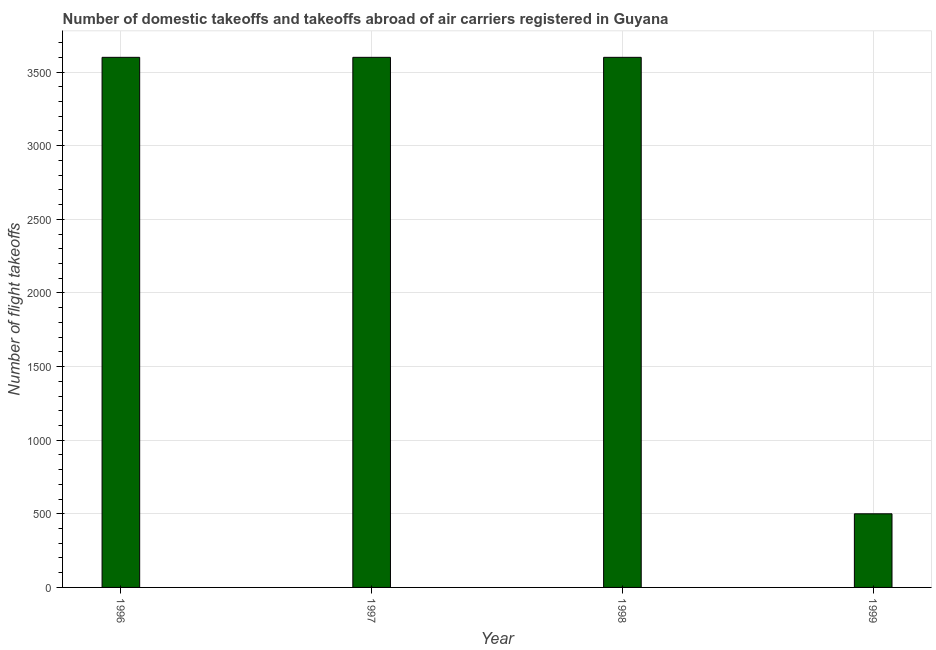Does the graph contain grids?
Give a very brief answer. Yes. What is the title of the graph?
Provide a succinct answer. Number of domestic takeoffs and takeoffs abroad of air carriers registered in Guyana. What is the label or title of the X-axis?
Your response must be concise. Year. What is the label or title of the Y-axis?
Ensure brevity in your answer.  Number of flight takeoffs. What is the number of flight takeoffs in 1998?
Make the answer very short. 3600. Across all years, what is the maximum number of flight takeoffs?
Provide a short and direct response. 3600. In which year was the number of flight takeoffs minimum?
Offer a very short reply. 1999. What is the sum of the number of flight takeoffs?
Make the answer very short. 1.13e+04. What is the difference between the number of flight takeoffs in 1997 and 1999?
Give a very brief answer. 3100. What is the average number of flight takeoffs per year?
Offer a very short reply. 2825. What is the median number of flight takeoffs?
Your answer should be very brief. 3600. What is the difference between the highest and the second highest number of flight takeoffs?
Make the answer very short. 0. What is the difference between the highest and the lowest number of flight takeoffs?
Your response must be concise. 3100. In how many years, is the number of flight takeoffs greater than the average number of flight takeoffs taken over all years?
Give a very brief answer. 3. Are the values on the major ticks of Y-axis written in scientific E-notation?
Provide a succinct answer. No. What is the Number of flight takeoffs of 1996?
Your response must be concise. 3600. What is the Number of flight takeoffs of 1997?
Give a very brief answer. 3600. What is the Number of flight takeoffs in 1998?
Give a very brief answer. 3600. What is the Number of flight takeoffs of 1999?
Give a very brief answer. 500. What is the difference between the Number of flight takeoffs in 1996 and 1999?
Provide a succinct answer. 3100. What is the difference between the Number of flight takeoffs in 1997 and 1999?
Keep it short and to the point. 3100. What is the difference between the Number of flight takeoffs in 1998 and 1999?
Keep it short and to the point. 3100. 